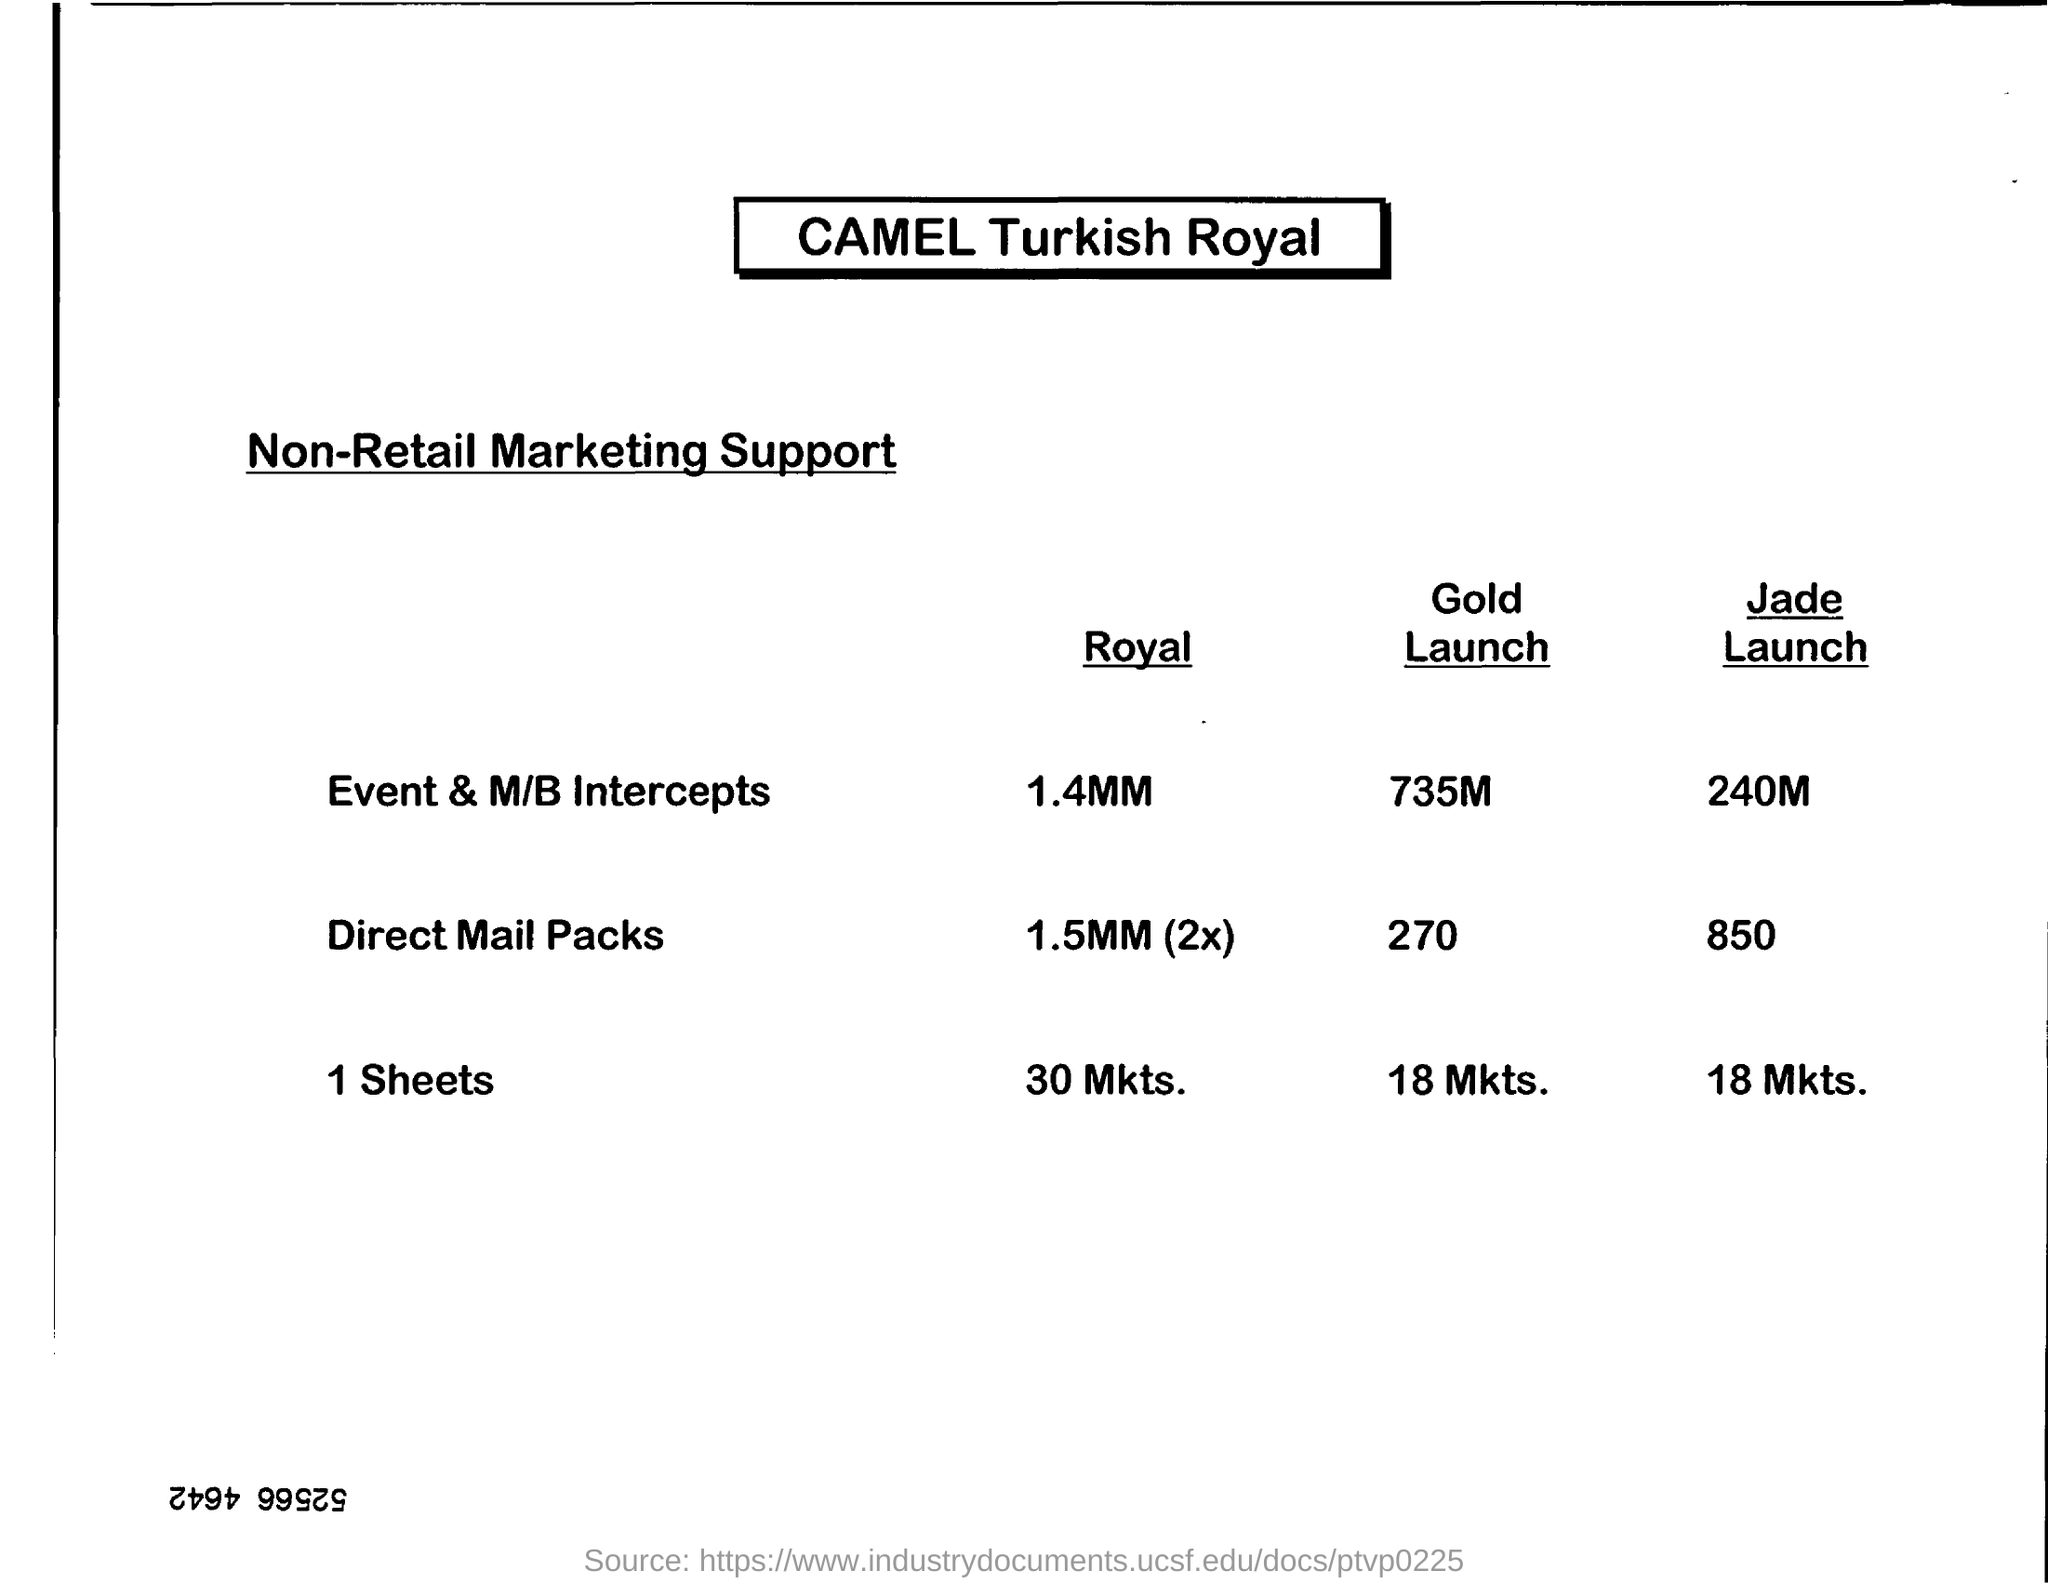What is the Direct Mail Packs for Gold Launch?
Provide a succinct answer. 270. What is the Direct Mail Packs for Jade Launch?
Your answer should be very brief. 850. 